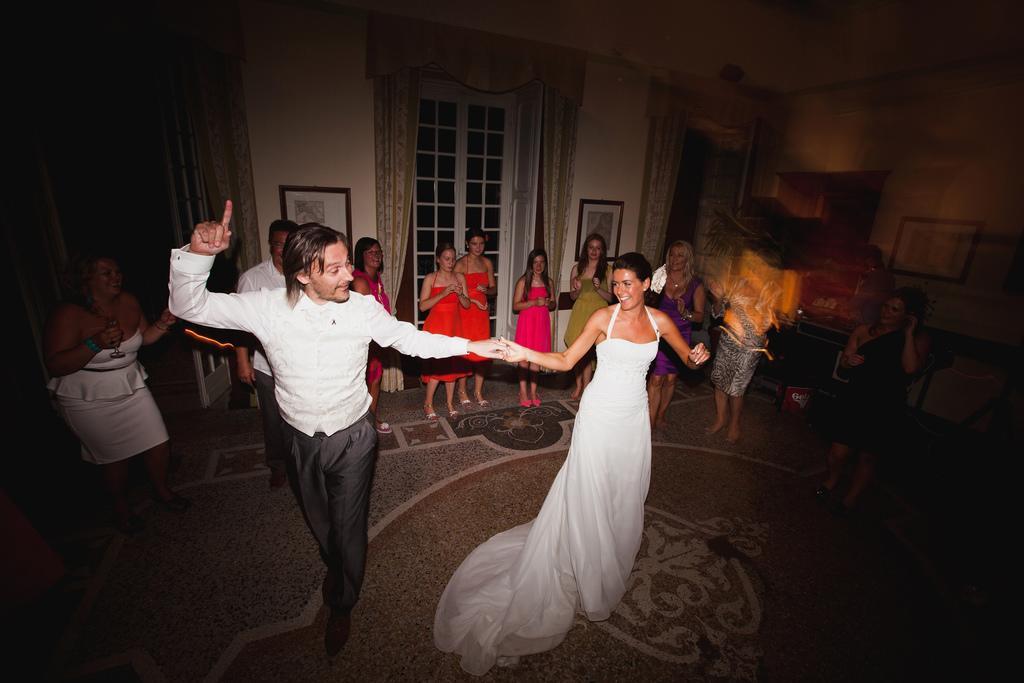Please provide a concise description of this image. In this image I can see a person wearing white and black dress and a woman wearing white dress are standing. In the background I can see few persons standing, few windows, few curtains, the wall and few photo frames attached to the wall. 